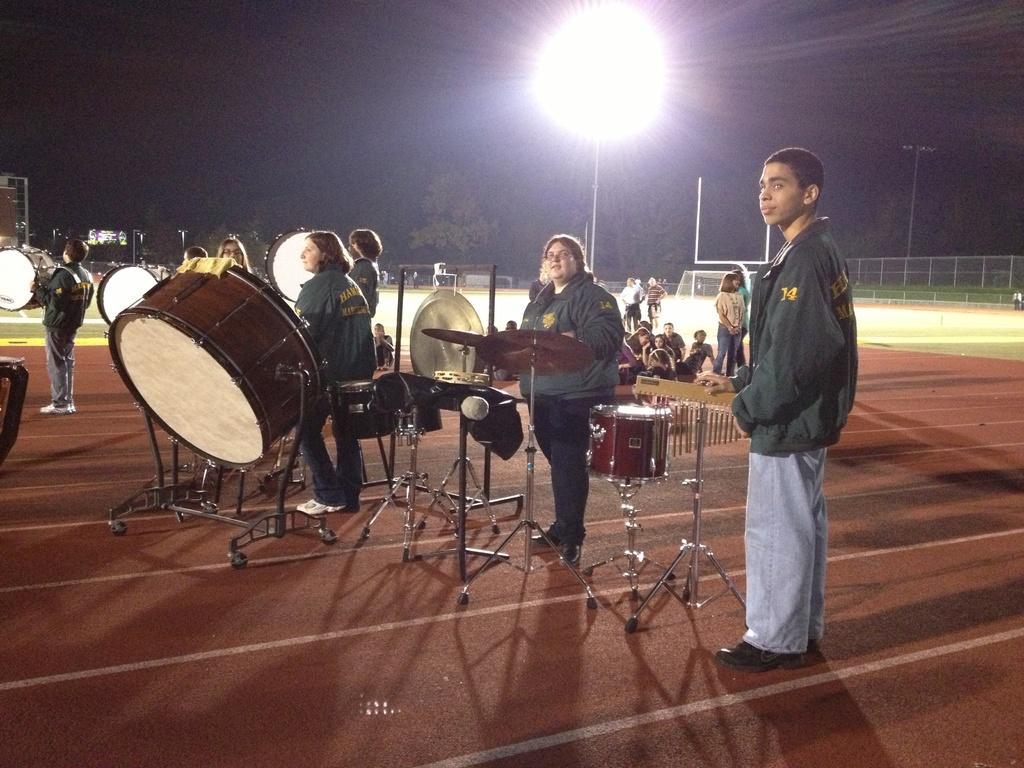Please provide a concise description of this image. In the picture we can see an orchestra troop playing a music in the playground and some people are sitting on the ground and watching them and in the background, we can see some fencing wall, besides we can see trees and sky. 